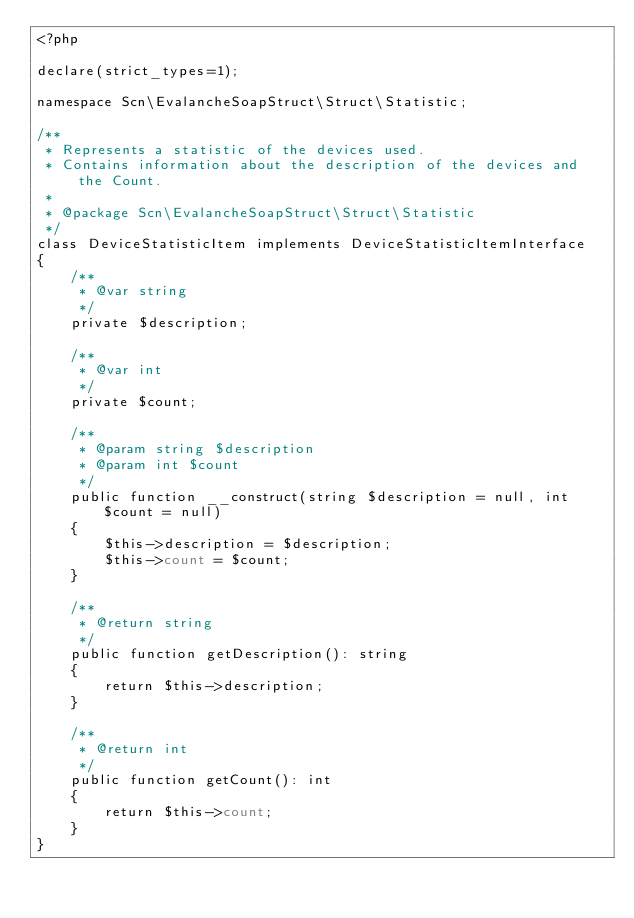Convert code to text. <code><loc_0><loc_0><loc_500><loc_500><_PHP_><?php

declare(strict_types=1);

namespace Scn\EvalancheSoapStruct\Struct\Statistic;

/**
 * Represents a statistic of the devices used.
 * Contains information about the description of the devices and the Count.
 *
 * @package Scn\EvalancheSoapStruct\Struct\Statistic
 */
class DeviceStatisticItem implements DeviceStatisticItemInterface
{
    /**
     * @var string
     */
    private $description;

    /**
     * @var int
     */
    private $count;

    /**
     * @param string $description
     * @param int $count
     */
    public function __construct(string $description = null, int $count = null)
    {
        $this->description = $description;
        $this->count = $count;
    }

    /**
     * @return string
     */
    public function getDescription(): string
    {
        return $this->description;
    }

    /**
     * @return int
     */
    public function getCount(): int
    {
        return $this->count;
    }
}
</code> 